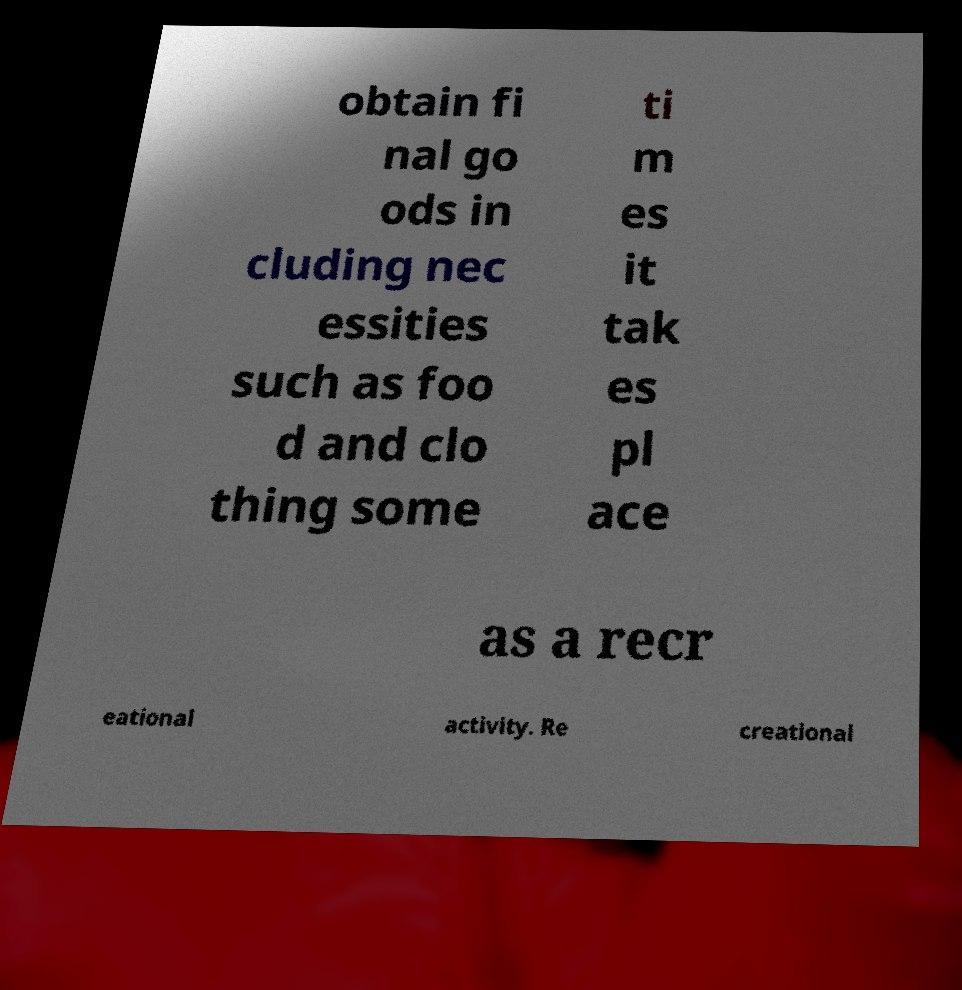Please read and relay the text visible in this image. What does it say? obtain fi nal go ods in cluding nec essities such as foo d and clo thing some ti m es it tak es pl ace as a recr eational activity. Re creational 